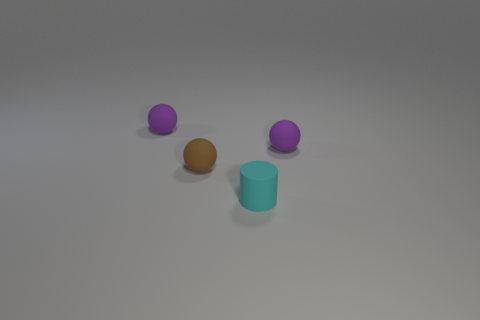There is a cyan cylinder that is left of the tiny purple sphere in front of the tiny purple rubber sphere to the left of the cyan matte cylinder; how big is it?
Keep it short and to the point. Small. There is a cylinder; are there any small brown matte objects on the right side of it?
Provide a short and direct response. No. There is a brown thing; is it the same size as the purple matte object to the left of the brown sphere?
Ensure brevity in your answer.  Yes. What number of other objects are there of the same material as the cylinder?
Your answer should be compact. 3. There is a small rubber thing that is behind the small brown sphere and to the left of the tiny cyan cylinder; what is its shape?
Provide a succinct answer. Sphere. Is the size of the matte object that is in front of the small brown matte ball the same as the rubber ball on the right side of the small cyan cylinder?
Your answer should be compact. Yes. There is a cyan thing that is made of the same material as the tiny brown sphere; what is its shape?
Your response must be concise. Cylinder. Is there any other thing that is the same shape as the brown thing?
Keep it short and to the point. Yes. There is a matte cylinder to the right of the small purple thing that is on the left side of the tiny ball that is right of the tiny cyan cylinder; what is its color?
Your answer should be compact. Cyan. Is the number of brown matte things in front of the small brown sphere less than the number of brown things that are in front of the cyan rubber object?
Ensure brevity in your answer.  No. 